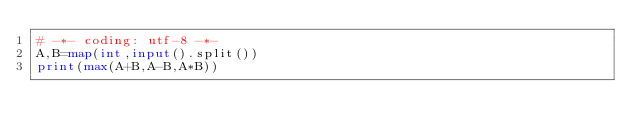Convert code to text. <code><loc_0><loc_0><loc_500><loc_500><_Python_># -*- coding: utf-8 -*-
A,B=map(int,input().split())
print(max(A+B,A-B,A*B))</code> 